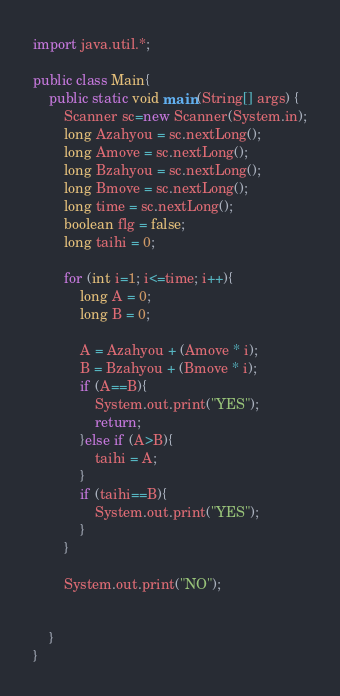<code> <loc_0><loc_0><loc_500><loc_500><_Java_>import java.util.*;
 
public class Main{
	public static void main(String[] args) {
	    Scanner sc=new Scanner(System.in);
		long Azahyou = sc.nextLong();
      	long Amove = sc.nextLong();
      	long Bzahyou = sc.nextLong();
      	long Bmove = sc.nextLong();
      	long time = sc.nextLong();
      	boolean flg = false;
      	long taihi = 0;
      	
      	for (int i=1; i<=time; i++){
          	long A = 0;
      		long B = 0;

      		A = Azahyou + (Amove * i);
      		B = Bzahyou + (Bmove * i);
            if (A==B){
          		System.out.print("YES");
              	return;
        	}else if (A>B){
              	taihi = A;
            }
            if (taihi==B){
                System.out.print("YES");
            }
        }
      
        System.out.print("NO");

		
	}
}</code> 